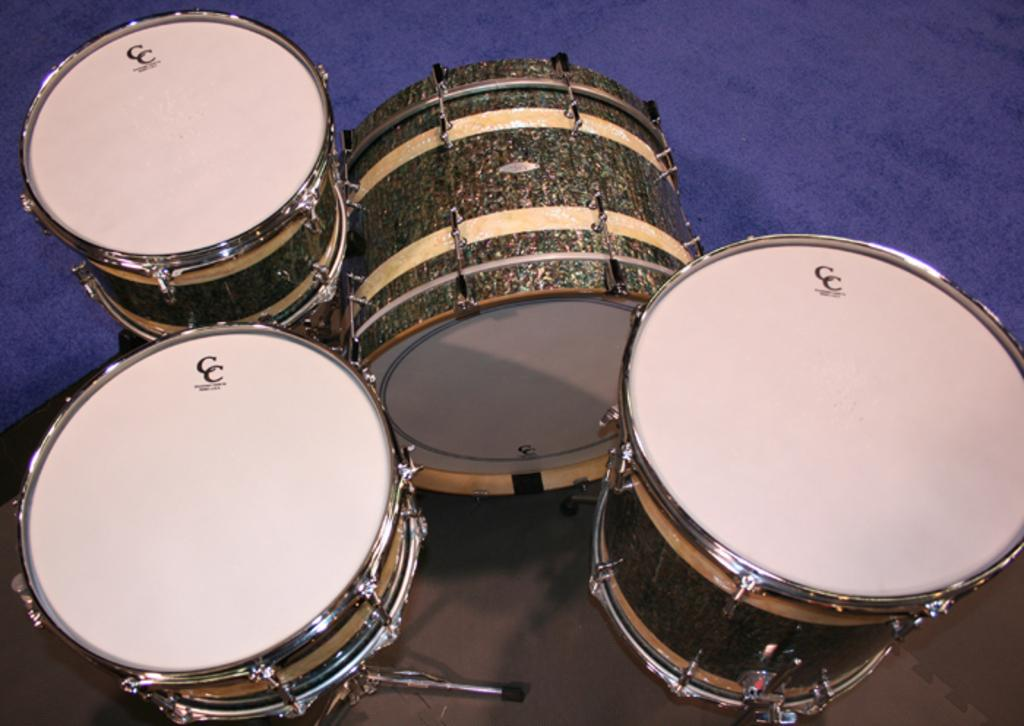What type of musical instrument is present in the image? There are drums in the image. What colors can be seen on the drums? The drums are in white and brown colors. What can be seen in the background of the image? There is a blue cloth in the background of the image. How does the group solve arithmetic problems using their brains in the image? There is no group or arithmetic problems present in the image; it only features drums and a blue cloth in the background. 